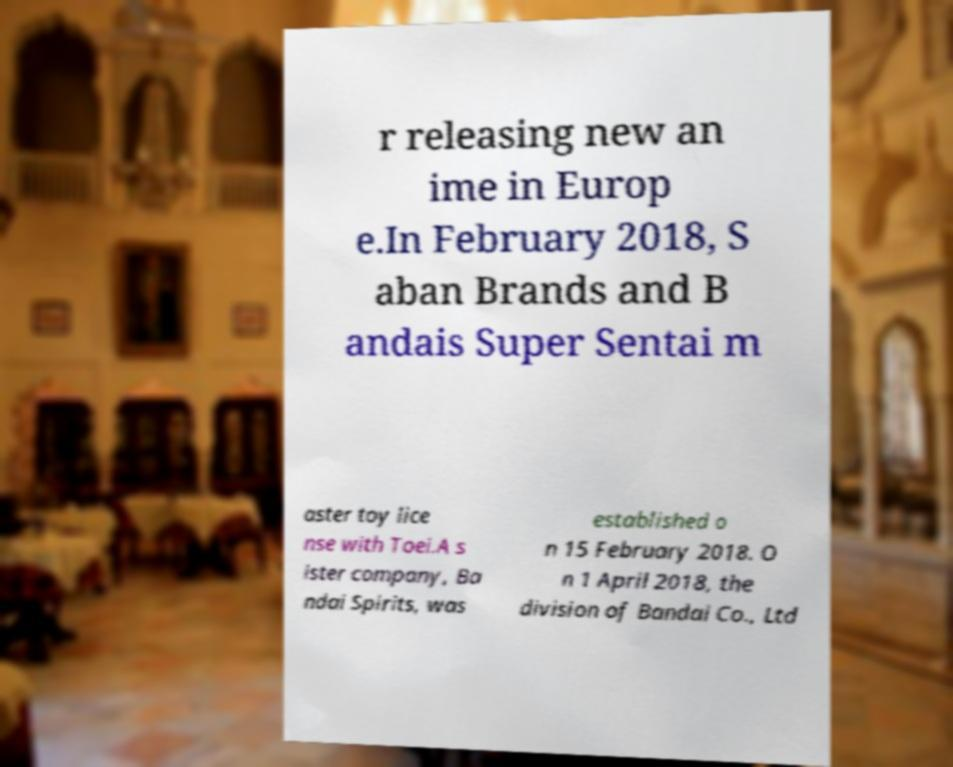Please identify and transcribe the text found in this image. r releasing new an ime in Europ e.In February 2018, S aban Brands and B andais Super Sentai m aster toy lice nse with Toei.A s ister company, Ba ndai Spirits, was established o n 15 February 2018. O n 1 April 2018, the division of Bandai Co., Ltd 